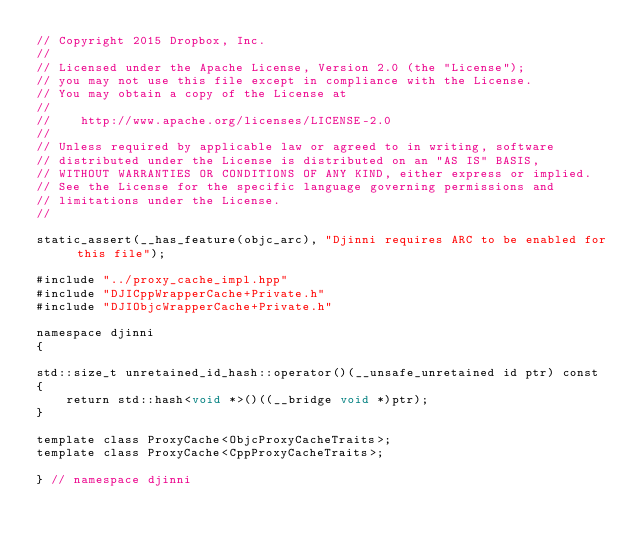Convert code to text. <code><loc_0><loc_0><loc_500><loc_500><_ObjectiveC_>// Copyright 2015 Dropbox, Inc.
//
// Licensed under the Apache License, Version 2.0 (the "License");
// you may not use this file except in compliance with the License.
// You may obtain a copy of the License at
//
//    http://www.apache.org/licenses/LICENSE-2.0
//
// Unless required by applicable law or agreed to in writing, software
// distributed under the License is distributed on an "AS IS" BASIS,
// WITHOUT WARRANTIES OR CONDITIONS OF ANY KIND, either express or implied.
// See the License for the specific language governing permissions and
// limitations under the License.
//

static_assert(__has_feature(objc_arc), "Djinni requires ARC to be enabled for this file");

#include "../proxy_cache_impl.hpp"
#include "DJICppWrapperCache+Private.h"
#include "DJIObjcWrapperCache+Private.h"

namespace djinni
{

std::size_t unretained_id_hash::operator()(__unsafe_unretained id ptr) const
{
    return std::hash<void *>()((__bridge void *)ptr);
}

template class ProxyCache<ObjcProxyCacheTraits>;
template class ProxyCache<CppProxyCacheTraits>;

} // namespace djinni
</code> 